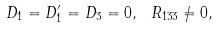<formula> <loc_0><loc_0><loc_500><loc_500>D _ { 1 } = D _ { 1 } ^ { \prime } = D _ { 3 } = 0 , \ R _ { 1 3 3 } \neq 0 ,</formula> 